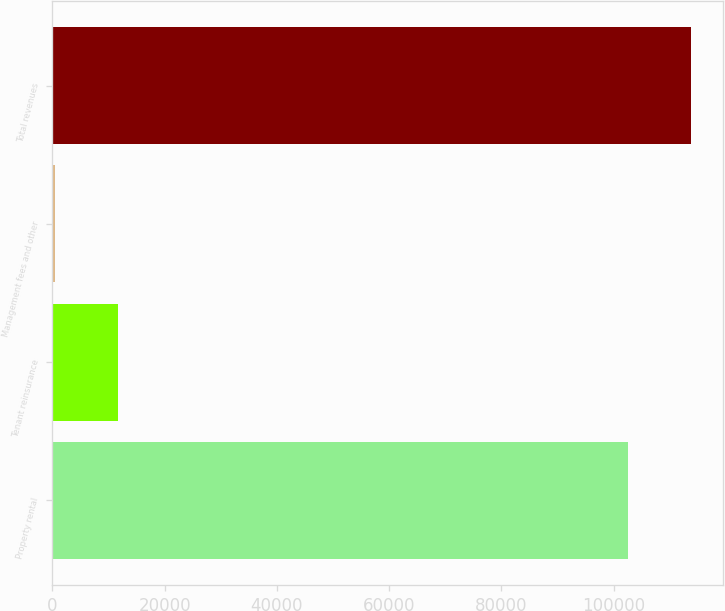<chart> <loc_0><loc_0><loc_500><loc_500><bar_chart><fcel>Property rental<fcel>Tenant reinsurance<fcel>Management fees and other<fcel>Total revenues<nl><fcel>102487<fcel>11730.1<fcel>463<fcel>113754<nl></chart> 